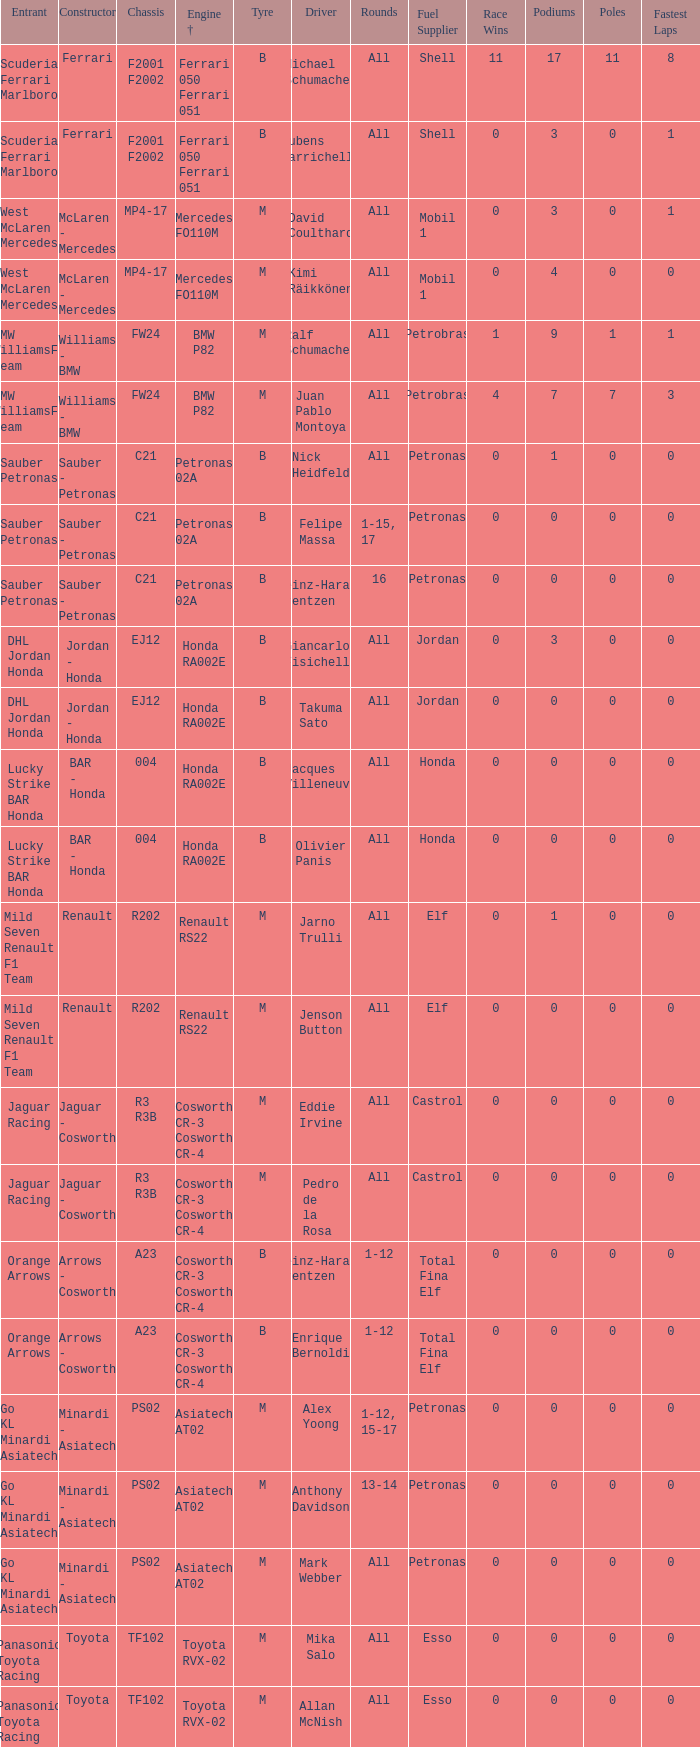What is the engine when the rounds ar all, the tyre is m and the driver is david coulthard? Mercedes FO110M. 